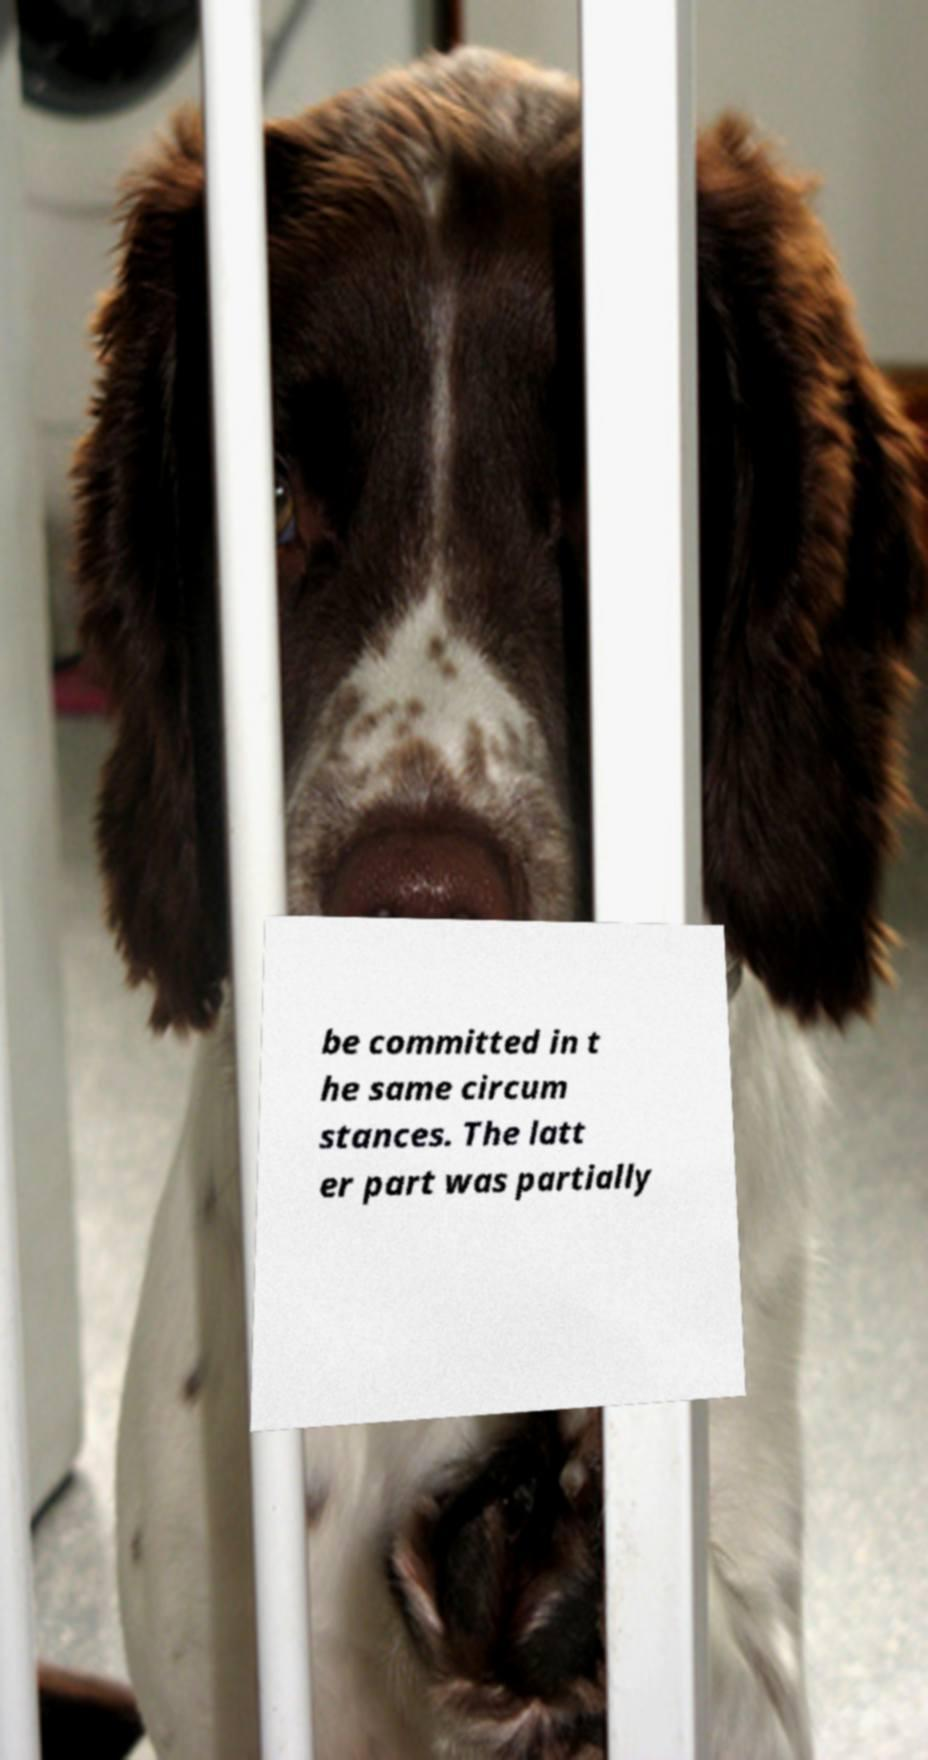For documentation purposes, I need the text within this image transcribed. Could you provide that? be committed in t he same circum stances. The latt er part was partially 